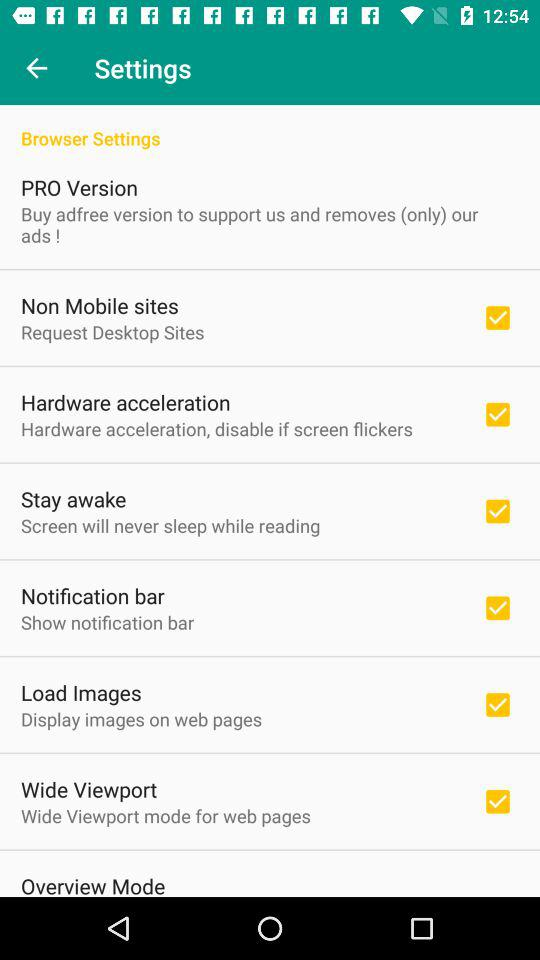What type of version is it? It is the type of "PRO Version". 